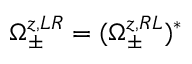Convert formula to latex. <formula><loc_0><loc_0><loc_500><loc_500>\Omega _ { \pm } ^ { z , L R } = ( \Omega _ { \pm } ^ { z , R L } ) ^ { * }</formula> 